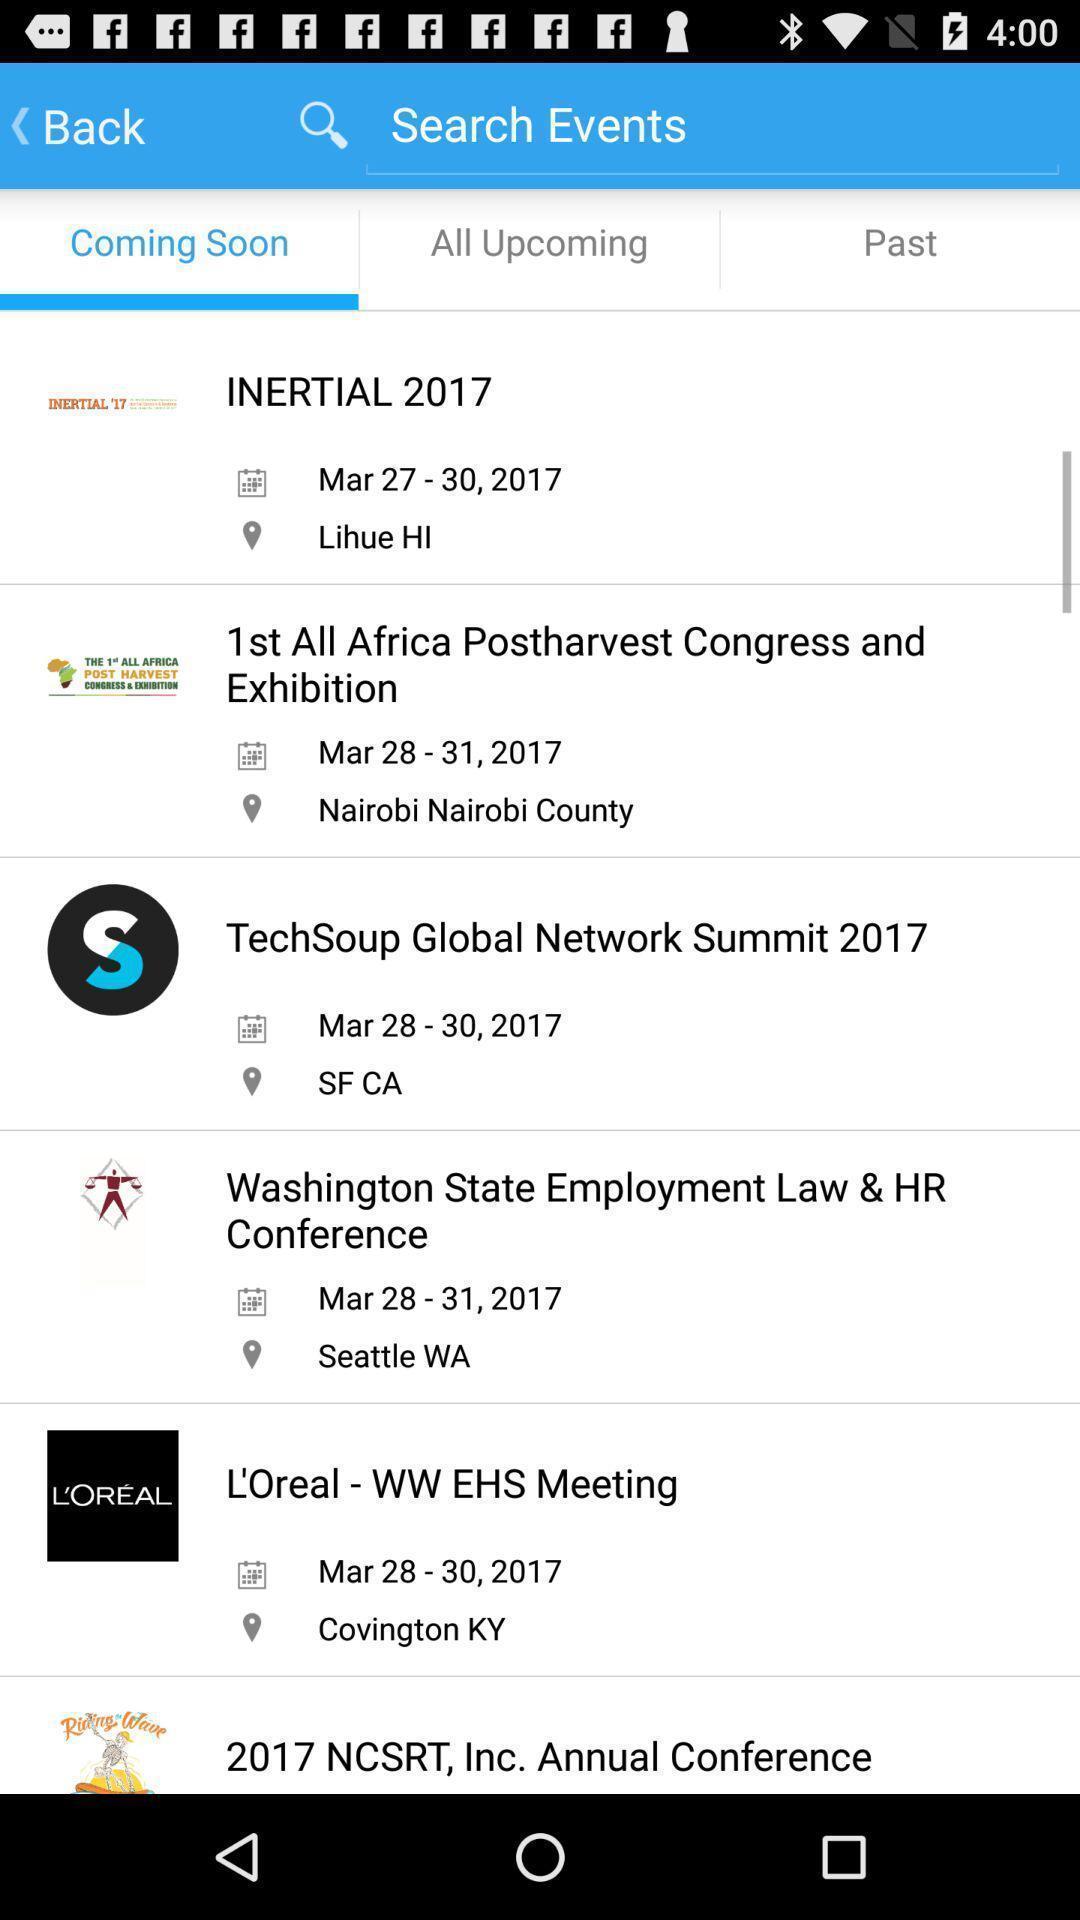Describe the content in this image. Result page of events search. 